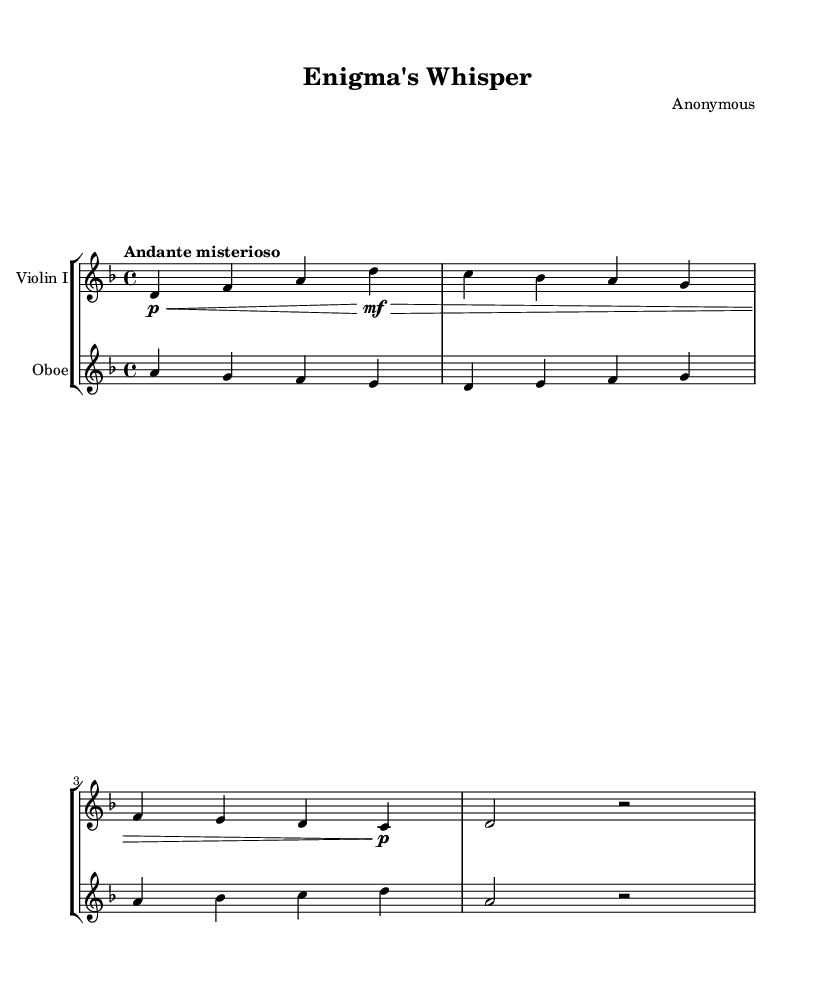What is the key signature of this music? The key signature indicates D minor, which has one flat (B flat). We find this at the beginning of the staff before the first note.
Answer: D minor What is the time signature of this music? The time signature is found at the beginning of the piece, indicating how many beats are in each measure. Here, it shows 4/4, meaning there are four beats per measure.
Answer: 4/4 What is the tempo marking for this piece? The tempo marking is indicated at the beginning of the score. In this case, it is "Andante misterioso," suggesting a moderate speed with a mysterious character.
Answer: Andante misterioso How many measures are in the provided music? By counting the measures from the start to the end of the excerpt, we find there are four distinct measures. Each set of notes separated by vertical lines corresponds to one measure.
Answer: Four What instruments are included in this piece? The instruments are specified at the beginning of each staff. One staff is labeled "Violin I," and the other is labeled "Oboe," indicating these are the instruments for this score.
Answer: Violin I, Oboe Which instrument plays the first note? The first note appears in the staff labeled for "Violin I." By looking at the score from left to right, we see it starts with a D note for the violin.
Answer: Violin I What is the dynamic marking for the first note in Violin I? The dynamic marking for the first note is shown as "p<," meaning it starts piano (softly) and crescendos. This is indicated right next to the first note in the violin part.
Answer: Piano 